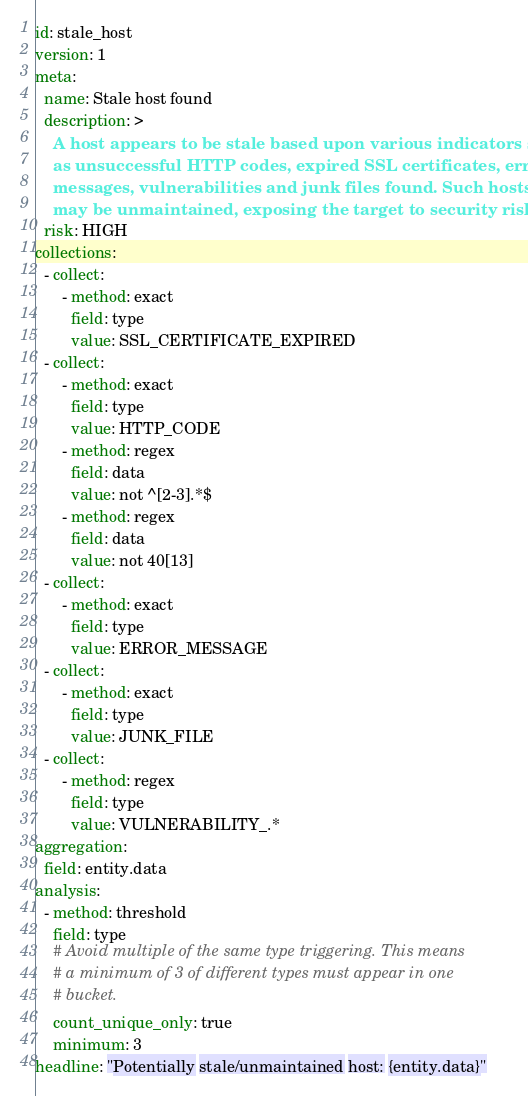<code> <loc_0><loc_0><loc_500><loc_500><_YAML_>id: stale_host
version: 1
meta:
  name: Stale host found
  description: >
    A host appears to be stale based upon various indicators such
    as unsuccessful HTTP codes, expired SSL certificates, error
    messages, vulnerabilities and junk files found. Such hosts
    may be unmaintained, exposing the target to security risks.
  risk: HIGH
collections:
  - collect:
      - method: exact
        field: type
        value: SSL_CERTIFICATE_EXPIRED
  - collect:
      - method: exact
        field: type
        value: HTTP_CODE
      - method: regex
        field: data
        value: not ^[2-3].*$
      - method: regex
        field: data
        value: not 40[13]
  - collect:
      - method: exact
        field: type
        value: ERROR_MESSAGE
  - collect:
      - method: exact
        field: type
        value: JUNK_FILE
  - collect:
      - method: regex
        field: type
        value: VULNERABILITY_.*
aggregation:
  field: entity.data
analysis:
  - method: threshold
    field: type
    # Avoid multiple of the same type triggering. This means
    # a minimum of 3 of different types must appear in one
    # bucket.
    count_unique_only: true
    minimum: 3
headline: "Potentially stale/unmaintained host: {entity.data}"
</code> 